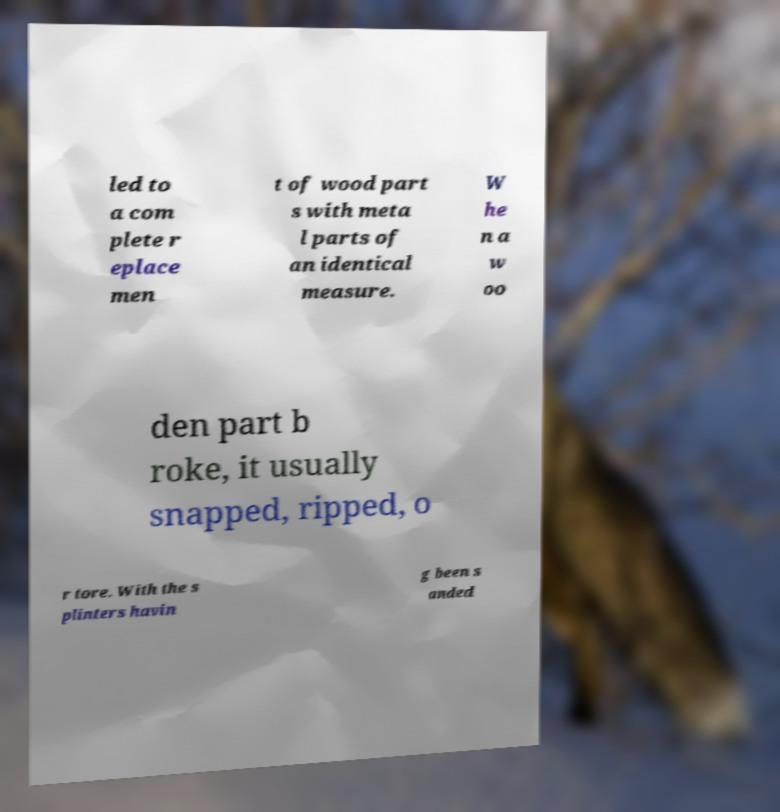Can you read and provide the text displayed in the image?This photo seems to have some interesting text. Can you extract and type it out for me? led to a com plete r eplace men t of wood part s with meta l parts of an identical measure. W he n a w oo den part b roke, it usually snapped, ripped, o r tore. With the s plinters havin g been s anded 